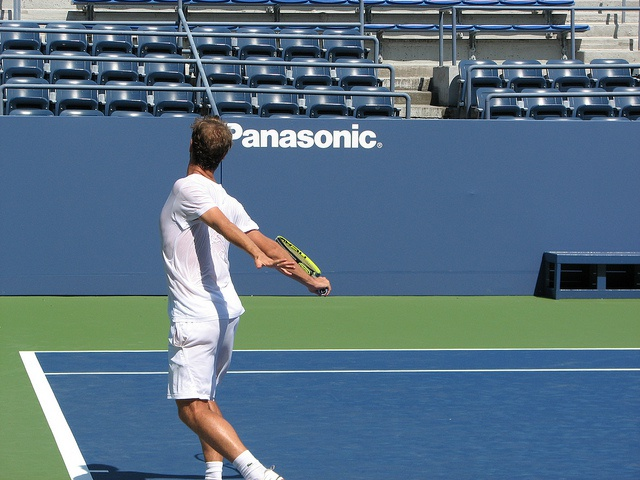Describe the objects in this image and their specific colors. I can see chair in teal, black, gray, and blue tones, people in teal, lavender, gray, and darkgray tones, bench in teal, black, blue, gray, and navy tones, chair in teal, black, gray, blue, and navy tones, and chair in teal, black, gray, blue, and navy tones in this image. 